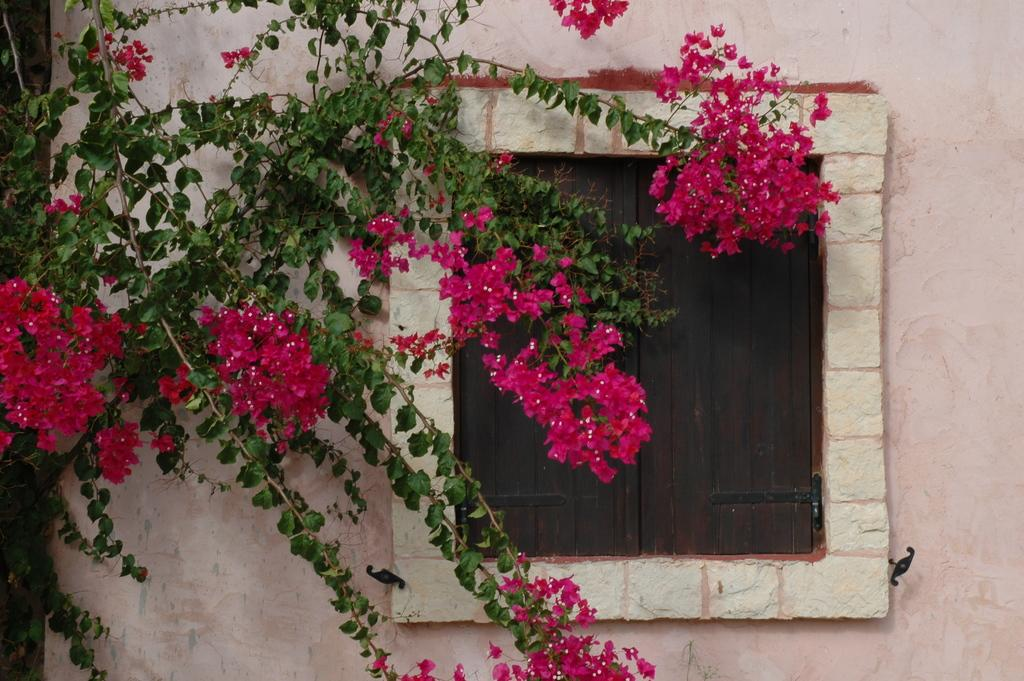What type of structure can be seen in the image? There is a wall in the image. Is there any opening in the wall? Yes, there is a window in the image. What can be seen through the window? Flowers are visible in the image. What is the color of the flowers? The flowers are pink in color. What else can be seen in the image besides the flowers? There are leaves visible in the image. Can you tell me how many riddles are hidden in the throat of the wall in the image? There are no riddles hidden in the throat of the wall in the image, as the wall does not have a throat. 